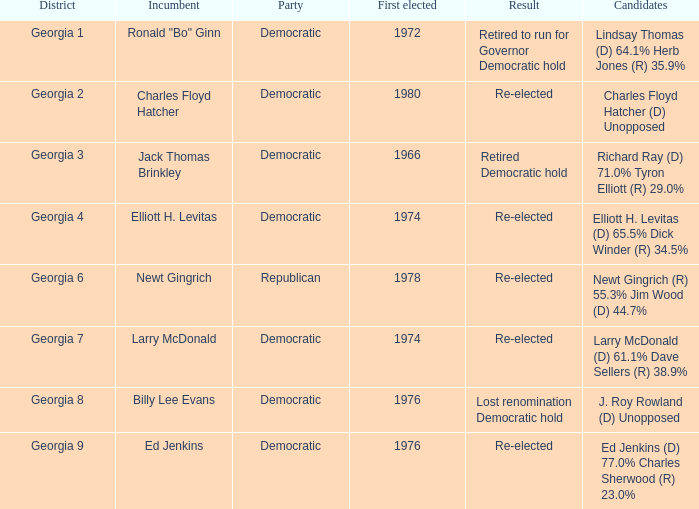Identify the candidates competing in georgia's 8th district election. J. Roy Rowland (D) Unopposed. 